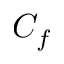Convert formula to latex. <formula><loc_0><loc_0><loc_500><loc_500>C _ { f }</formula> 